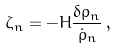Convert formula to latex. <formula><loc_0><loc_0><loc_500><loc_500>\zeta _ { n } = - H \frac { \delta \rho _ { n } } { \dot { \rho } _ { n } } \, ,</formula> 